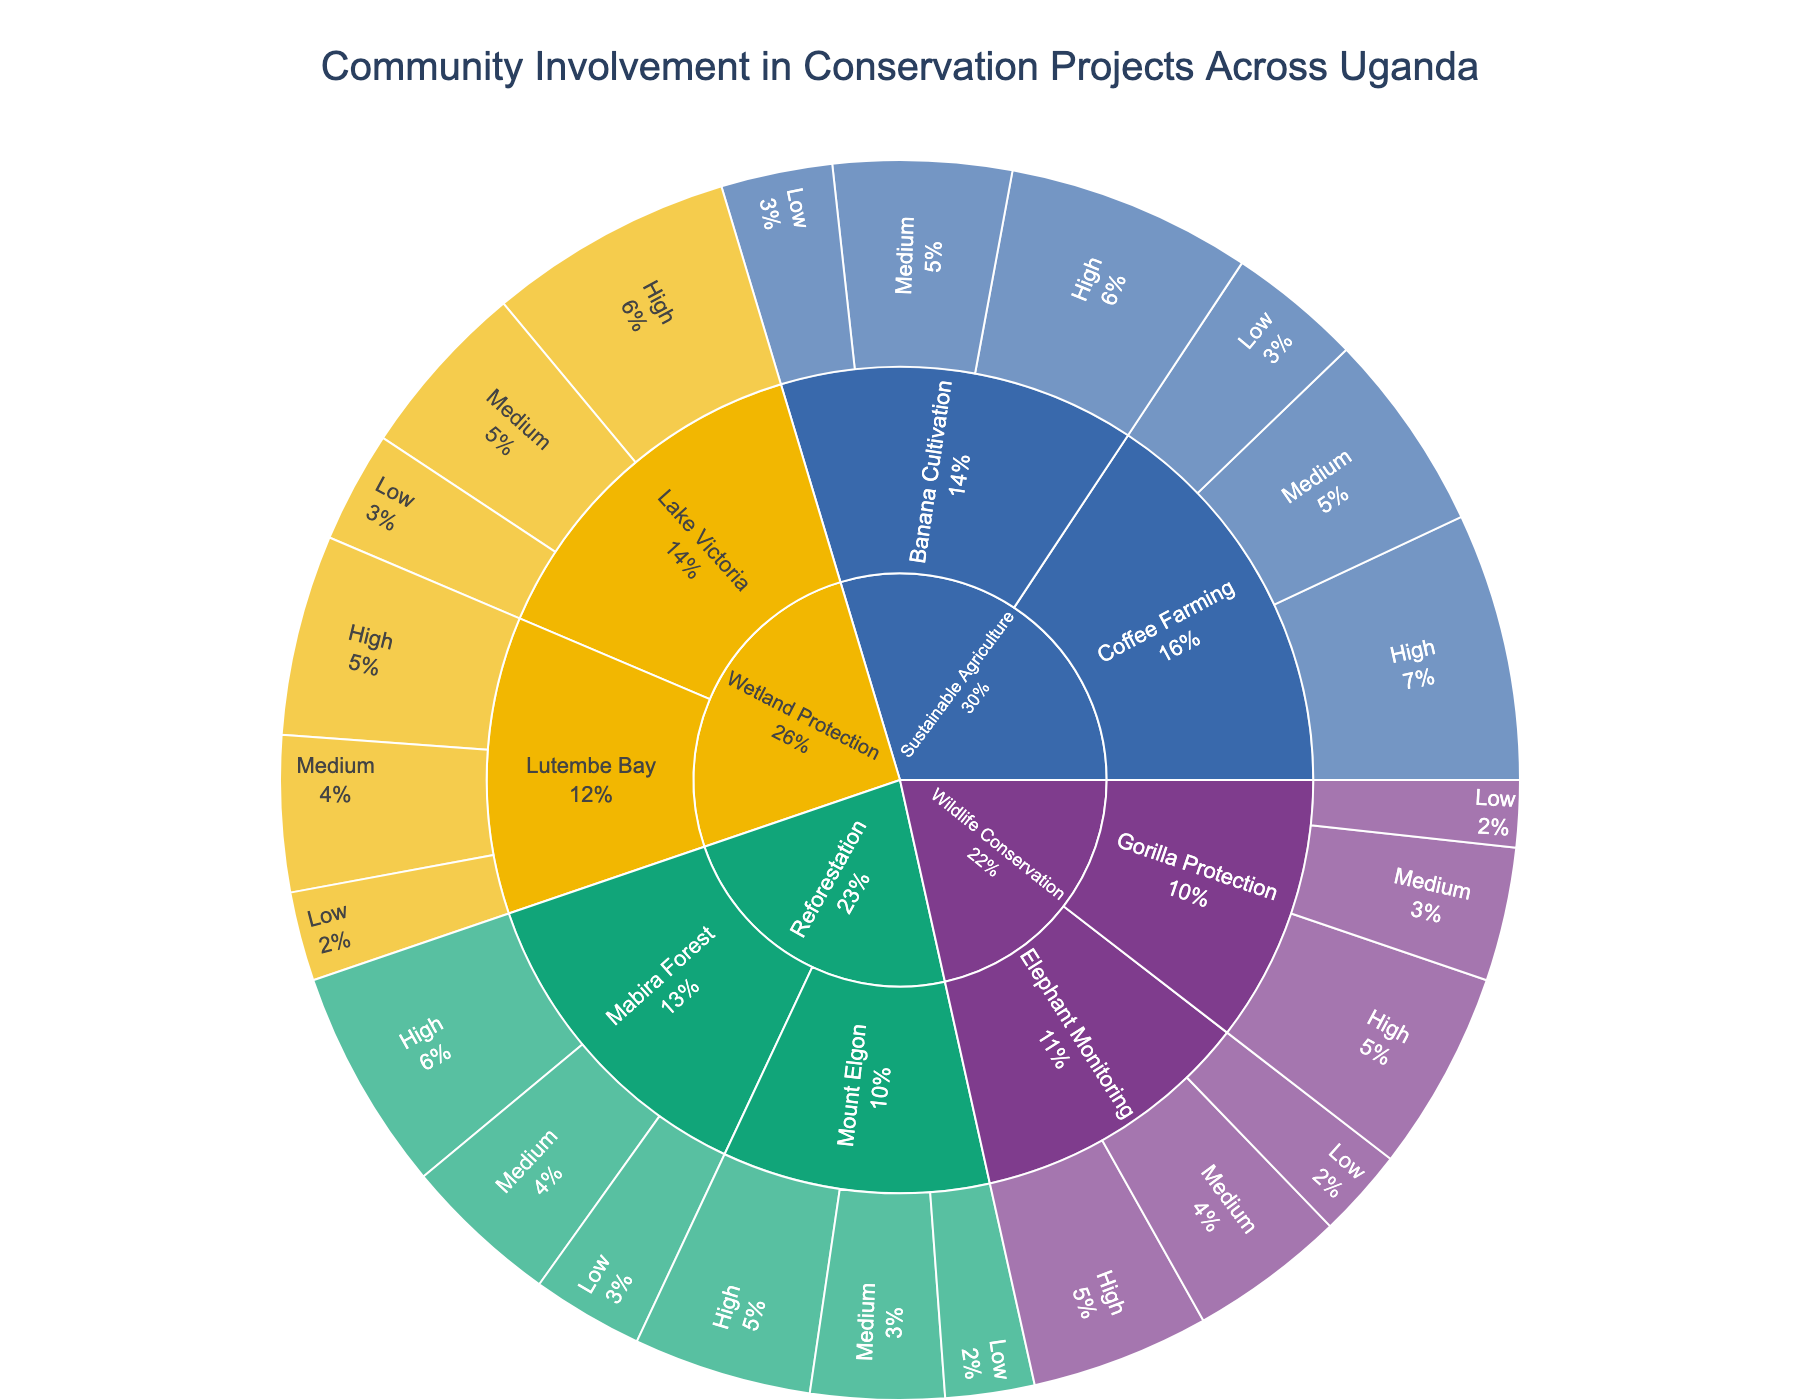what is the title of the figure? The title is usually found at the top of the figure and provides a summary of what the figure represents. For this figure, it is "Community Involvement in Conservation Projects Across Uganda".
Answer: Community Involvement in Conservation Projects Across Uganda How many overall project types are illustrated in the figure? To find the overall project types, look for the first level of the hierarchy in the sunburst plot, which typically has the main categories like "Wildlife Conservation", "Reforestation", "Wetland Protection", and "Sustainable Agriculture". There are four main categories.
Answer: 4 Which project type has the highest overall community involvement at High participation level? To determine this, identify the "High" levels of participation within each project type and compare their values. The "Sustainable Agriculture" project, with 60 (Coffee Farming) and 55 (Banana Cultivation), has the highest overall community involvement at the High participation level.
Answer: Sustainable Agriculture What is the total value of Medium participation in Wildlife Conservation projects? Sum the values for all entries within "Wildlife Conservation" that have a participation level of "Medium": 30 (Gorilla Protection) + 35 (Elephant Monitoring) = 65.
Answer: 65 Compare the community involvement at Low participation level between Lake Victoria and Lutembe Bay in Wetland Protection projects. Which one is higher? Identify the values for "Low" participation in both Lake Victoria (25) and Lutembe Bay (20) and compare them. Lake Victoria has a higher value.
Answer: Lake Victoria What is the combined community involvement for High participation levels in all Reforestation projects? Add the values for "High" participation in "Mabira Forest" (50) and "Mount Elgon" (40) to get the total: 50 + 40 = 90.
Answer: 90 Which sub-category of Wetland Protection has the lowest community involvement at the Medium participation level? Compare the values for "Medium" participation in Wetland Protection sub-categories: Lake Victoria (40) and Lutembe Bay (35). Lutembe Bay has the lower value.
Answer: Lutembe Bay How does the community involvement in Gorilla Protection at all participation levels compare to that in Elephant Monitoring? Sum the values for each level of participation in both categories: Gorilla Protection: 45 (High) + 30 (Medium) + 15 (Low) = 90; Elephant Monitoring: 40 (High) + 35 (Medium) + 20 (Low) = 95. Elephant Monitoring has a higher overall community involvement.
Answer: Elephant Monitoring Order the project types by total community involvement starting from the highest. Sum all participation levels for each project type and then compare:  
- Wildlife Conservation: 45+30+15+40+35+20 = 185
- Reforestation: 50+35+25+40+30+20 = 200
- Wetland Protection: 55+40+25+45+35+20 = 220
- Sustainable Agriculture: 60+45+30+55+40+25 = 255
So, the order from highest to lowest is Sustainable Agriculture, Wetland Protection, Reforestation, Wildlife Conservation.
Answer: Sustainable Agriculture, Wetland Protection, Reforestation, Wildlife Conservation 